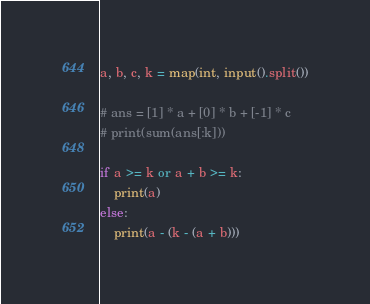Convert code to text. <code><loc_0><loc_0><loc_500><loc_500><_Python_>a, b, c, k = map(int, input().split())

# ans = [1] * a + [0] * b + [-1] * c
# print(sum(ans[:k]))

if a >= k or a + b >= k:
    print(a)
else:
    print(a - (k - (a + b)))</code> 